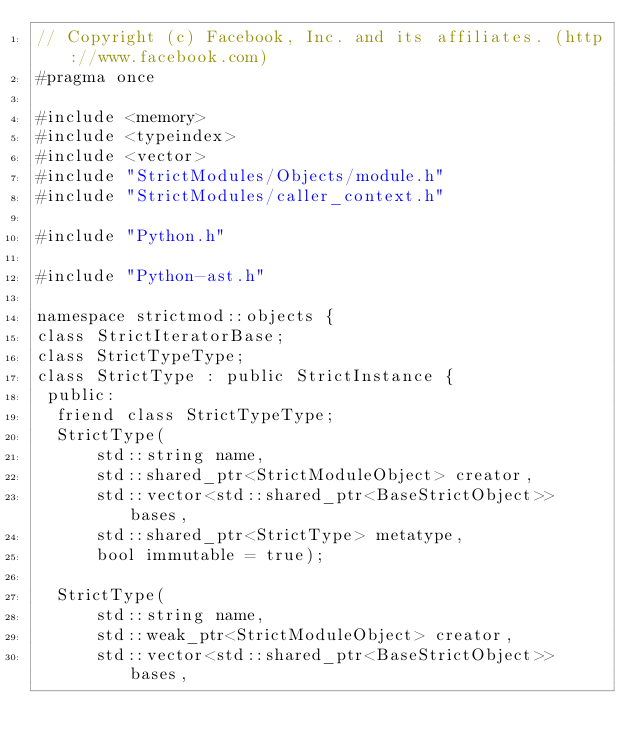Convert code to text. <code><loc_0><loc_0><loc_500><loc_500><_C_>// Copyright (c) Facebook, Inc. and its affiliates. (http://www.facebook.com)
#pragma once

#include <memory>
#include <typeindex>
#include <vector>
#include "StrictModules/Objects/module.h"
#include "StrictModules/caller_context.h"

#include "Python.h"

#include "Python-ast.h"

namespace strictmod::objects {
class StrictIteratorBase;
class StrictTypeType;
class StrictType : public StrictInstance {
 public:
  friend class StrictTypeType;
  StrictType(
      std::string name,
      std::shared_ptr<StrictModuleObject> creator,
      std::vector<std::shared_ptr<BaseStrictObject>> bases,
      std::shared_ptr<StrictType> metatype,
      bool immutable = true);

  StrictType(
      std::string name,
      std::weak_ptr<StrictModuleObject> creator,
      std::vector<std::shared_ptr<BaseStrictObject>> bases,</code> 